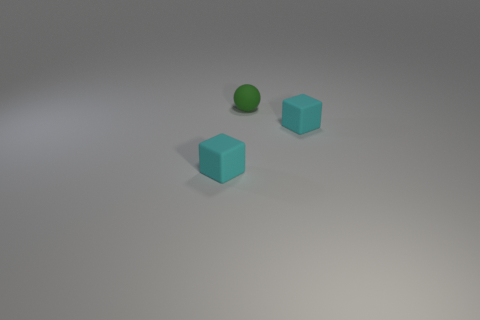Based on the objects' arrangement, what simple geometrical shapes are represented? The objects in the image form basic geometrical shapes: the blocks are cubes, and the green object is a sphere. 